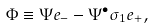<formula> <loc_0><loc_0><loc_500><loc_500>\Phi \equiv \Psi e _ { - } - \Psi ^ { \bullet } \sigma _ { 1 } e _ { + } ,</formula> 